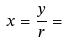<formula> <loc_0><loc_0><loc_500><loc_500>x = \frac { y } { r } =</formula> 